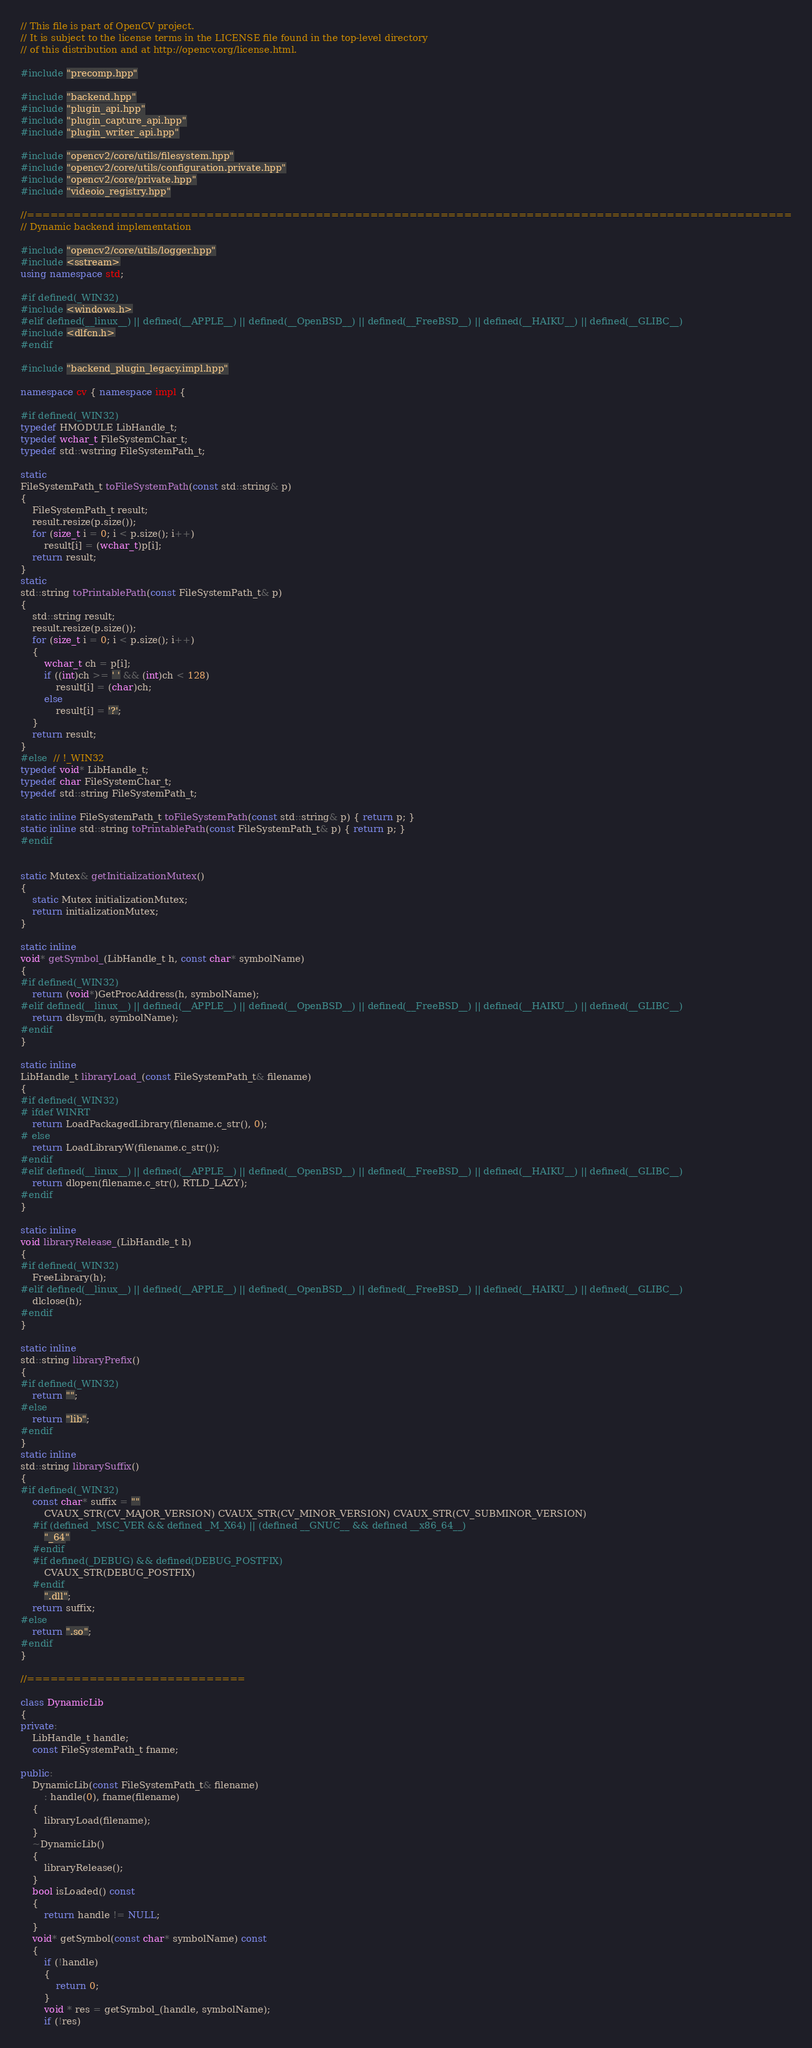<code> <loc_0><loc_0><loc_500><loc_500><_C++_>// This file is part of OpenCV project.
// It is subject to the license terms in the LICENSE file found in the top-level directory
// of this distribution and at http://opencv.org/license.html.

#include "precomp.hpp"

#include "backend.hpp"
#include "plugin_api.hpp"
#include "plugin_capture_api.hpp"
#include "plugin_writer_api.hpp"

#include "opencv2/core/utils/filesystem.hpp"
#include "opencv2/core/utils/configuration.private.hpp"
#include "opencv2/core/private.hpp"
#include "videoio_registry.hpp"

//==================================================================================================
// Dynamic backend implementation

#include "opencv2/core/utils/logger.hpp"
#include <sstream>
using namespace std;

#if defined(_WIN32)
#include <windows.h>
#elif defined(__linux__) || defined(__APPLE__) || defined(__OpenBSD__) || defined(__FreeBSD__) || defined(__HAIKU__) || defined(__GLIBC__)
#include <dlfcn.h>
#endif

#include "backend_plugin_legacy.impl.hpp"

namespace cv { namespace impl {

#if defined(_WIN32)
typedef HMODULE LibHandle_t;
typedef wchar_t FileSystemChar_t;
typedef std::wstring FileSystemPath_t;

static
FileSystemPath_t toFileSystemPath(const std::string& p)
{
    FileSystemPath_t result;
    result.resize(p.size());
    for (size_t i = 0; i < p.size(); i++)
        result[i] = (wchar_t)p[i];
    return result;
}
static
std::string toPrintablePath(const FileSystemPath_t& p)
{
    std::string result;
    result.resize(p.size());
    for (size_t i = 0; i < p.size(); i++)
    {
        wchar_t ch = p[i];
        if ((int)ch >= ' ' && (int)ch < 128)
            result[i] = (char)ch;
        else
            result[i] = '?';
    }
    return result;
}
#else  // !_WIN32
typedef void* LibHandle_t;
typedef char FileSystemChar_t;
typedef std::string FileSystemPath_t;

static inline FileSystemPath_t toFileSystemPath(const std::string& p) { return p; }
static inline std::string toPrintablePath(const FileSystemPath_t& p) { return p; }
#endif


static Mutex& getInitializationMutex()
{
    static Mutex initializationMutex;
    return initializationMutex;
}

static inline
void* getSymbol_(LibHandle_t h, const char* symbolName)
{
#if defined(_WIN32)
    return (void*)GetProcAddress(h, symbolName);
#elif defined(__linux__) || defined(__APPLE__) || defined(__OpenBSD__) || defined(__FreeBSD__) || defined(__HAIKU__) || defined(__GLIBC__)
    return dlsym(h, symbolName);
#endif
}

static inline
LibHandle_t libraryLoad_(const FileSystemPath_t& filename)
{
#if defined(_WIN32)
# ifdef WINRT
    return LoadPackagedLibrary(filename.c_str(), 0);
# else
    return LoadLibraryW(filename.c_str());
#endif
#elif defined(__linux__) || defined(__APPLE__) || defined(__OpenBSD__) || defined(__FreeBSD__) || defined(__HAIKU__) || defined(__GLIBC__)
    return dlopen(filename.c_str(), RTLD_LAZY);
#endif
}

static inline
void libraryRelease_(LibHandle_t h)
{
#if defined(_WIN32)
    FreeLibrary(h);
#elif defined(__linux__) || defined(__APPLE__) || defined(__OpenBSD__) || defined(__FreeBSD__) || defined(__HAIKU__) || defined(__GLIBC__)
    dlclose(h);
#endif
}

static inline
std::string libraryPrefix()
{
#if defined(_WIN32)
    return "";
#else
    return "lib";
#endif
}
static inline
std::string librarySuffix()
{
#if defined(_WIN32)
    const char* suffix = ""
        CVAUX_STR(CV_MAJOR_VERSION) CVAUX_STR(CV_MINOR_VERSION) CVAUX_STR(CV_SUBMINOR_VERSION)
    #if (defined _MSC_VER && defined _M_X64) || (defined __GNUC__ && defined __x86_64__)
        "_64"
    #endif
    #if defined(_DEBUG) && defined(DEBUG_POSTFIX)
        CVAUX_STR(DEBUG_POSTFIX)
    #endif
        ".dll";
    return suffix;
#else
    return ".so";
#endif
}

//============================

class DynamicLib
{
private:
    LibHandle_t handle;
    const FileSystemPath_t fname;

public:
    DynamicLib(const FileSystemPath_t& filename)
        : handle(0), fname(filename)
    {
        libraryLoad(filename);
    }
    ~DynamicLib()
    {
        libraryRelease();
    }
    bool isLoaded() const
    {
        return handle != NULL;
    }
    void* getSymbol(const char* symbolName) const
    {
        if (!handle)
        {
            return 0;
        }
        void * res = getSymbol_(handle, symbolName);
        if (!res)</code> 